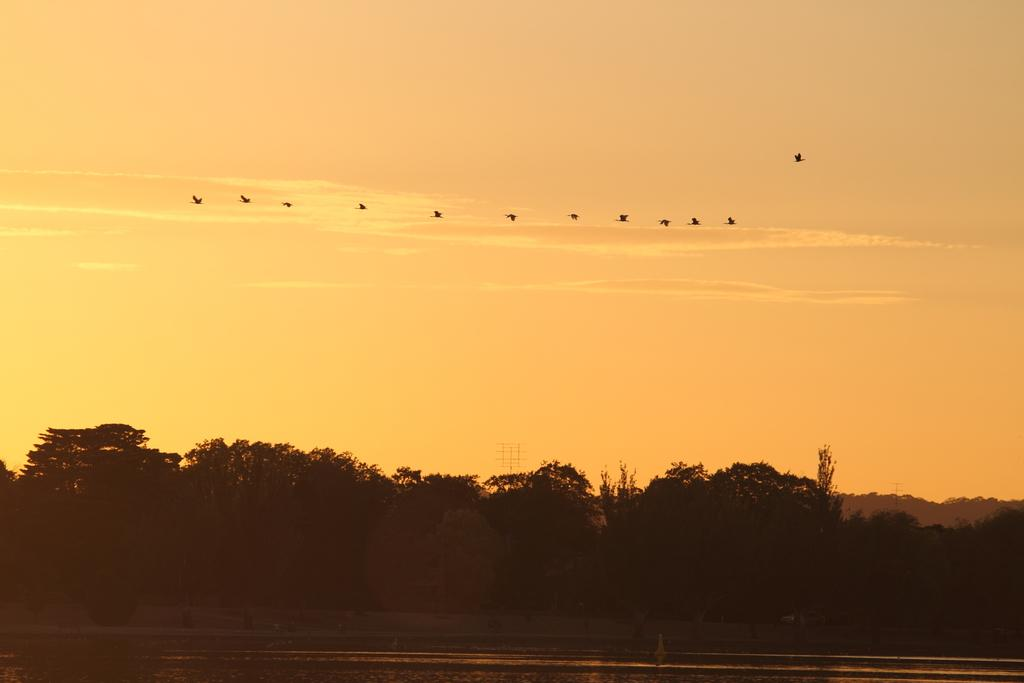What type of natural feature is present in the image? There is a river in the image. What other natural elements can be seen in the image? There are trees in the image. What is flying in the sky in the image? There are birds in the sky in the image. What type of mint is growing in the cellar in the image? There is no cellar or mint present in the image. What is being served for lunch in the image? There is no indication of lunch being served in the image. 